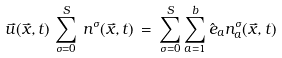Convert formula to latex. <formula><loc_0><loc_0><loc_500><loc_500>\vec { u } ( \vec { x } , t ) \, \sum _ { \sigma = 0 } ^ { S } \, n ^ { \sigma } ( \vec { x } , t ) \, = \, \sum _ { \sigma = 0 } ^ { S } \sum _ { a = 1 } ^ { b } \hat { e } _ { a } n _ { a } ^ { \sigma } ( \vec { x } , t )</formula> 